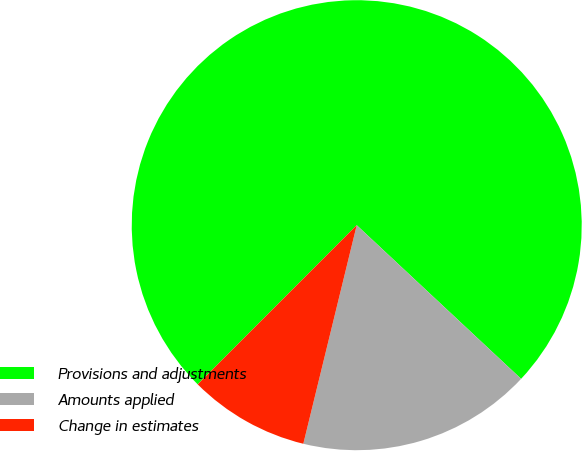Convert chart to OTSL. <chart><loc_0><loc_0><loc_500><loc_500><pie_chart><fcel>Provisions and adjustments<fcel>Amounts applied<fcel>Change in estimates<nl><fcel>74.47%<fcel>16.85%<fcel>8.68%<nl></chart> 